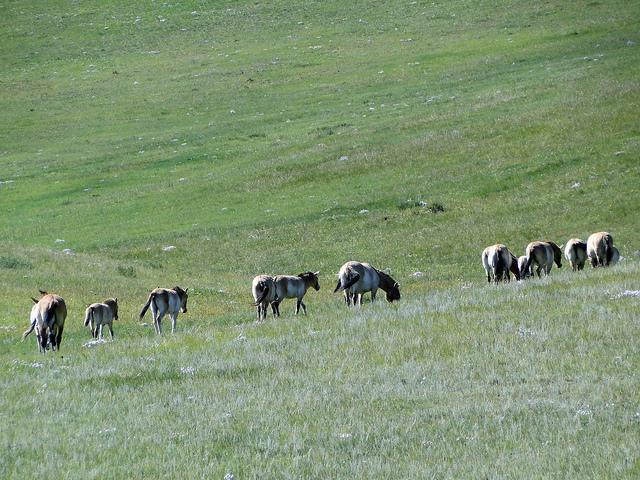How many red cars are there?
Give a very brief answer. 0. 